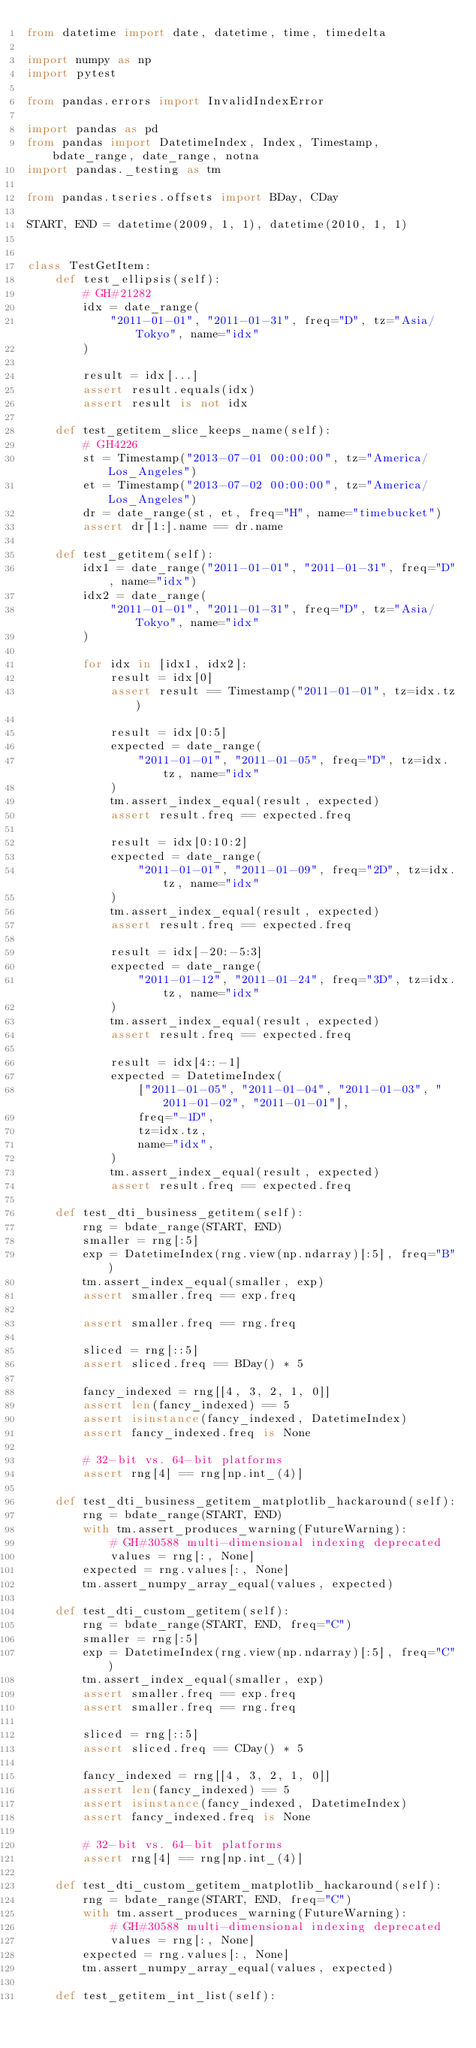Convert code to text. <code><loc_0><loc_0><loc_500><loc_500><_Python_>from datetime import date, datetime, time, timedelta

import numpy as np
import pytest

from pandas.errors import InvalidIndexError

import pandas as pd
from pandas import DatetimeIndex, Index, Timestamp, bdate_range, date_range, notna
import pandas._testing as tm

from pandas.tseries.offsets import BDay, CDay

START, END = datetime(2009, 1, 1), datetime(2010, 1, 1)


class TestGetItem:
    def test_ellipsis(self):
        # GH#21282
        idx = date_range(
            "2011-01-01", "2011-01-31", freq="D", tz="Asia/Tokyo", name="idx"
        )

        result = idx[...]
        assert result.equals(idx)
        assert result is not idx

    def test_getitem_slice_keeps_name(self):
        # GH4226
        st = Timestamp("2013-07-01 00:00:00", tz="America/Los_Angeles")
        et = Timestamp("2013-07-02 00:00:00", tz="America/Los_Angeles")
        dr = date_range(st, et, freq="H", name="timebucket")
        assert dr[1:].name == dr.name

    def test_getitem(self):
        idx1 = date_range("2011-01-01", "2011-01-31", freq="D", name="idx")
        idx2 = date_range(
            "2011-01-01", "2011-01-31", freq="D", tz="Asia/Tokyo", name="idx"
        )

        for idx in [idx1, idx2]:
            result = idx[0]
            assert result == Timestamp("2011-01-01", tz=idx.tz)

            result = idx[0:5]
            expected = date_range(
                "2011-01-01", "2011-01-05", freq="D", tz=idx.tz, name="idx"
            )
            tm.assert_index_equal(result, expected)
            assert result.freq == expected.freq

            result = idx[0:10:2]
            expected = date_range(
                "2011-01-01", "2011-01-09", freq="2D", tz=idx.tz, name="idx"
            )
            tm.assert_index_equal(result, expected)
            assert result.freq == expected.freq

            result = idx[-20:-5:3]
            expected = date_range(
                "2011-01-12", "2011-01-24", freq="3D", tz=idx.tz, name="idx"
            )
            tm.assert_index_equal(result, expected)
            assert result.freq == expected.freq

            result = idx[4::-1]
            expected = DatetimeIndex(
                ["2011-01-05", "2011-01-04", "2011-01-03", "2011-01-02", "2011-01-01"],
                freq="-1D",
                tz=idx.tz,
                name="idx",
            )
            tm.assert_index_equal(result, expected)
            assert result.freq == expected.freq

    def test_dti_business_getitem(self):
        rng = bdate_range(START, END)
        smaller = rng[:5]
        exp = DatetimeIndex(rng.view(np.ndarray)[:5], freq="B")
        tm.assert_index_equal(smaller, exp)
        assert smaller.freq == exp.freq

        assert smaller.freq == rng.freq

        sliced = rng[::5]
        assert sliced.freq == BDay() * 5

        fancy_indexed = rng[[4, 3, 2, 1, 0]]
        assert len(fancy_indexed) == 5
        assert isinstance(fancy_indexed, DatetimeIndex)
        assert fancy_indexed.freq is None

        # 32-bit vs. 64-bit platforms
        assert rng[4] == rng[np.int_(4)]

    def test_dti_business_getitem_matplotlib_hackaround(self):
        rng = bdate_range(START, END)
        with tm.assert_produces_warning(FutureWarning):
            # GH#30588 multi-dimensional indexing deprecated
            values = rng[:, None]
        expected = rng.values[:, None]
        tm.assert_numpy_array_equal(values, expected)

    def test_dti_custom_getitem(self):
        rng = bdate_range(START, END, freq="C")
        smaller = rng[:5]
        exp = DatetimeIndex(rng.view(np.ndarray)[:5], freq="C")
        tm.assert_index_equal(smaller, exp)
        assert smaller.freq == exp.freq
        assert smaller.freq == rng.freq

        sliced = rng[::5]
        assert sliced.freq == CDay() * 5

        fancy_indexed = rng[[4, 3, 2, 1, 0]]
        assert len(fancy_indexed) == 5
        assert isinstance(fancy_indexed, DatetimeIndex)
        assert fancy_indexed.freq is None

        # 32-bit vs. 64-bit platforms
        assert rng[4] == rng[np.int_(4)]

    def test_dti_custom_getitem_matplotlib_hackaround(self):
        rng = bdate_range(START, END, freq="C")
        with tm.assert_produces_warning(FutureWarning):
            # GH#30588 multi-dimensional indexing deprecated
            values = rng[:, None]
        expected = rng.values[:, None]
        tm.assert_numpy_array_equal(values, expected)

    def test_getitem_int_list(self):</code> 